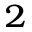<formula> <loc_0><loc_0><loc_500><loc_500>^ { 2 }</formula> 